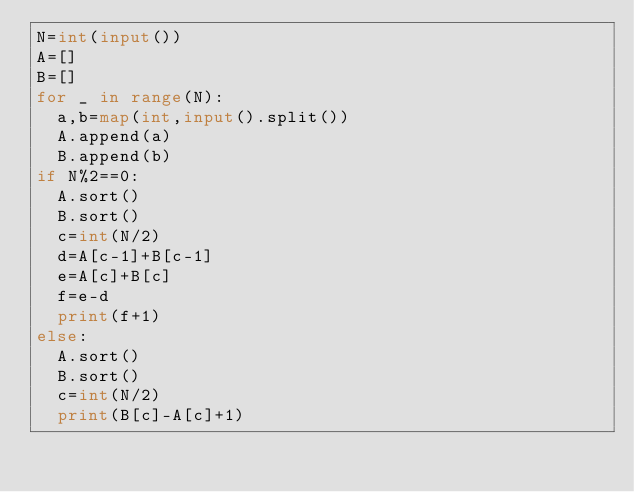<code> <loc_0><loc_0><loc_500><loc_500><_Python_>N=int(input())
A=[]
B=[]
for _ in range(N):
  a,b=map(int,input().split())
  A.append(a)
  B.append(b)
if N%2==0:
  A.sort()
  B.sort()
  c=int(N/2)
  d=A[c-1]+B[c-1]
  e=A[c]+B[c]
  f=e-d
  print(f+1)
else:
  A.sort()
  B.sort()
  c=int(N/2)
  print(B[c]-A[c]+1)</code> 